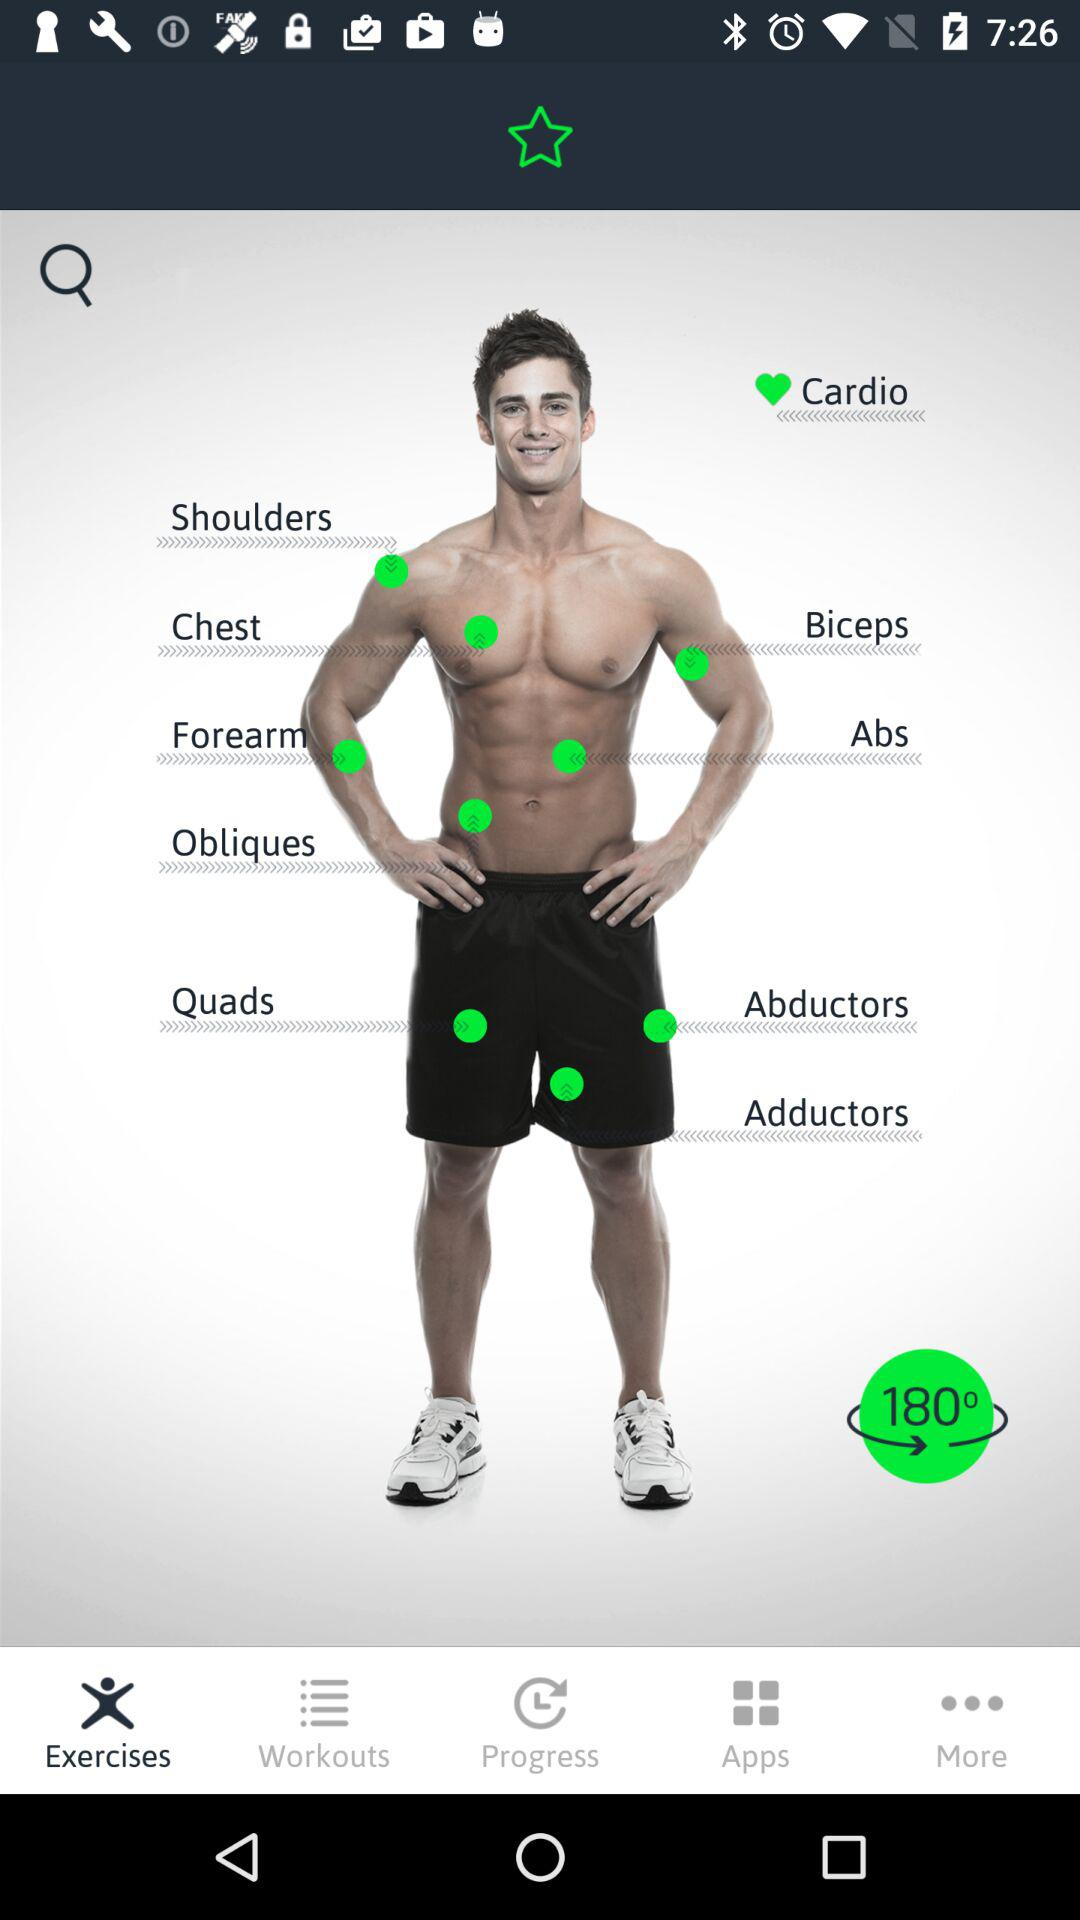What is the rotation angle? The rotation angle is 180°. 